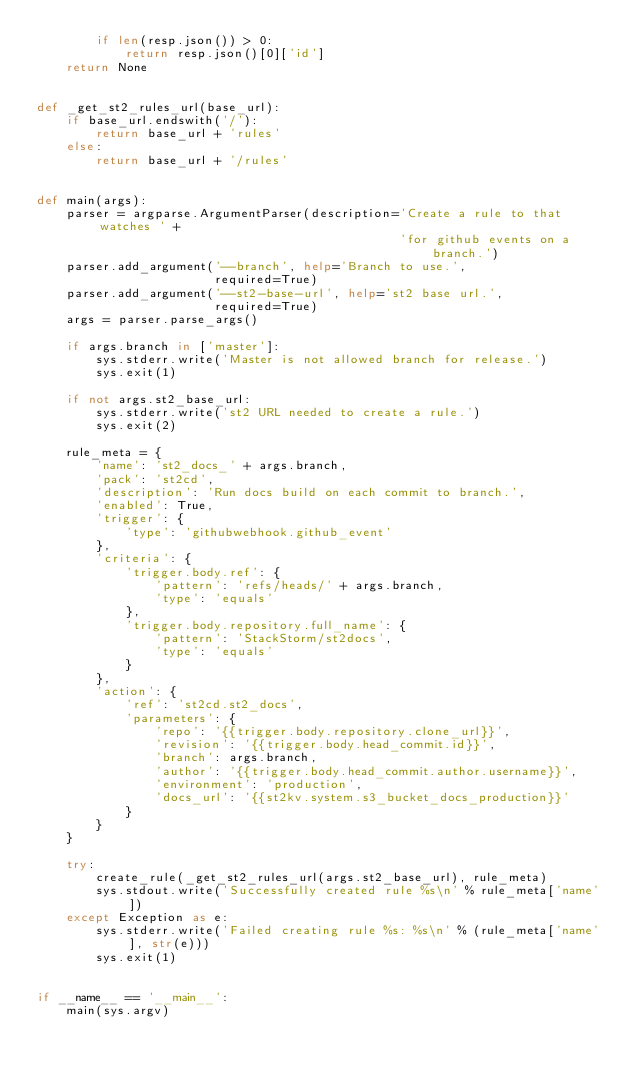<code> <loc_0><loc_0><loc_500><loc_500><_Python_>        if len(resp.json()) > 0:
            return resp.json()[0]['id']
    return None


def _get_st2_rules_url(base_url):
    if base_url.endswith('/'):
        return base_url + 'rules'
    else:
        return base_url + '/rules'


def main(args):
    parser = argparse.ArgumentParser(description='Create a rule to that watches ' +
                                                 'for github events on a branch.')
    parser.add_argument('--branch', help='Branch to use.',
                        required=True)
    parser.add_argument('--st2-base-url', help='st2 base url.',
                        required=True)
    args = parser.parse_args()

    if args.branch in ['master']:
        sys.stderr.write('Master is not allowed branch for release.')
        sys.exit(1)

    if not args.st2_base_url:
        sys.stderr.write('st2 URL needed to create a rule.')
        sys.exit(2)

    rule_meta = {
        'name': 'st2_docs_' + args.branch,
        'pack': 'st2cd',
        'description': 'Run docs build on each commit to branch.',
        'enabled': True,
        'trigger': {
            'type': 'githubwebhook.github_event'
        },
        'criteria': {
            'trigger.body.ref': {
                'pattern': 'refs/heads/' + args.branch,
                'type': 'equals'
            },
            'trigger.body.repository.full_name': {
                'pattern': 'StackStorm/st2docs',
                'type': 'equals'
            }
        },
        'action': {
            'ref': 'st2cd.st2_docs',
            'parameters': {
                'repo': '{{trigger.body.repository.clone_url}}',
                'revision': '{{trigger.body.head_commit.id}}',
                'branch': args.branch,
                'author': '{{trigger.body.head_commit.author.username}}',
                'environment': 'production',
                'docs_url': '{{st2kv.system.s3_bucket_docs_production}}'
            }
        }
    }

    try:
        create_rule(_get_st2_rules_url(args.st2_base_url), rule_meta)
        sys.stdout.write('Successfully created rule %s\n' % rule_meta['name'])
    except Exception as e:
        sys.stderr.write('Failed creating rule %s: %s\n' % (rule_meta['name'], str(e)))
        sys.exit(1)


if __name__ == '__main__':
    main(sys.argv)
</code> 